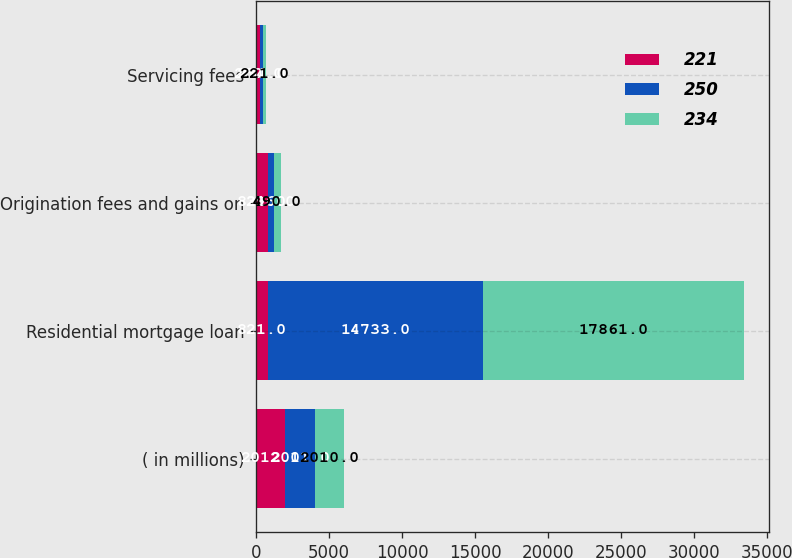<chart> <loc_0><loc_0><loc_500><loc_500><stacked_bar_chart><ecel><fcel>( in millions)<fcel>Residential mortgage loan<fcel>Origination fees and gains on<fcel>Servicing fees<nl><fcel>221<fcel>2012<fcel>821<fcel>821<fcel>250<nl><fcel>250<fcel>2011<fcel>14733<fcel>396<fcel>234<nl><fcel>234<fcel>2010<fcel>17861<fcel>490<fcel>221<nl></chart> 